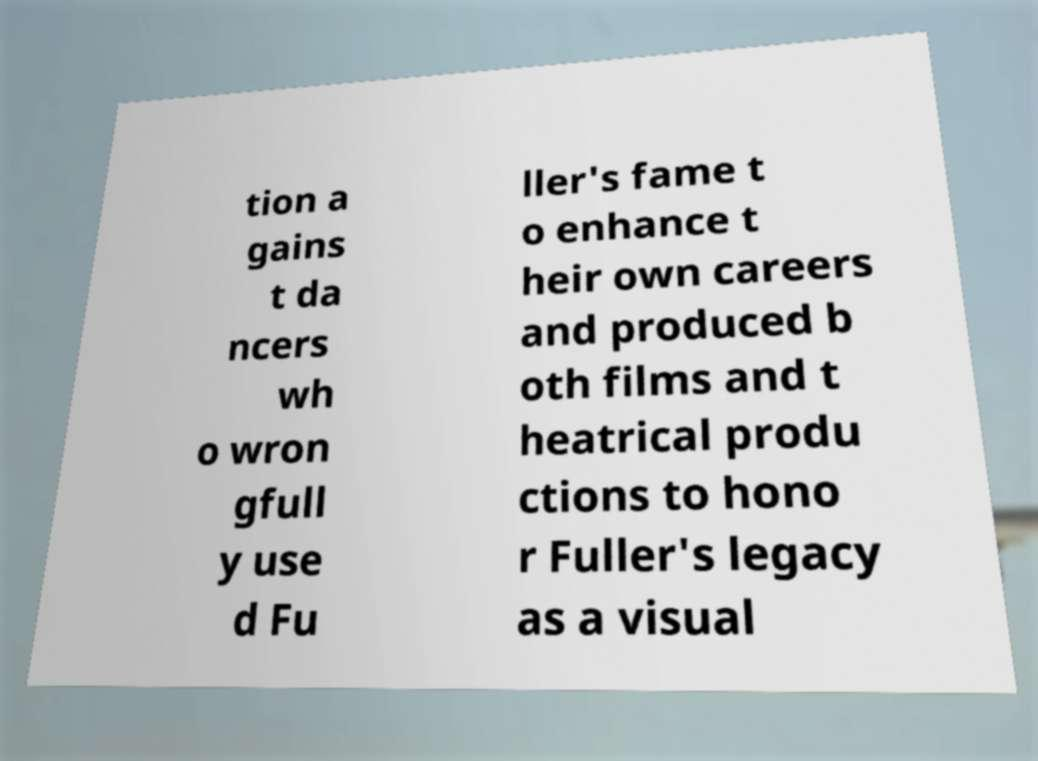Could you assist in decoding the text presented in this image and type it out clearly? tion a gains t da ncers wh o wron gfull y use d Fu ller's fame t o enhance t heir own careers and produced b oth films and t heatrical produ ctions to hono r Fuller's legacy as a visual 